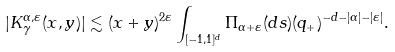Convert formula to latex. <formula><loc_0><loc_0><loc_500><loc_500>| K _ { \gamma } ^ { \alpha , \varepsilon } ( x , y ) | \lesssim ( x + y ) ^ { 2 \varepsilon } \int _ { [ - 1 , 1 ] ^ { d } } \Pi _ { \alpha + \varepsilon } ( d s ) ( q _ { + } ) ^ { - d - | \alpha | - | \varepsilon | } .</formula> 